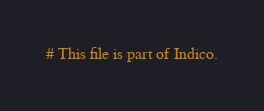Convert code to text. <code><loc_0><loc_0><loc_500><loc_500><_Python_># This file is part of Indico.</code> 